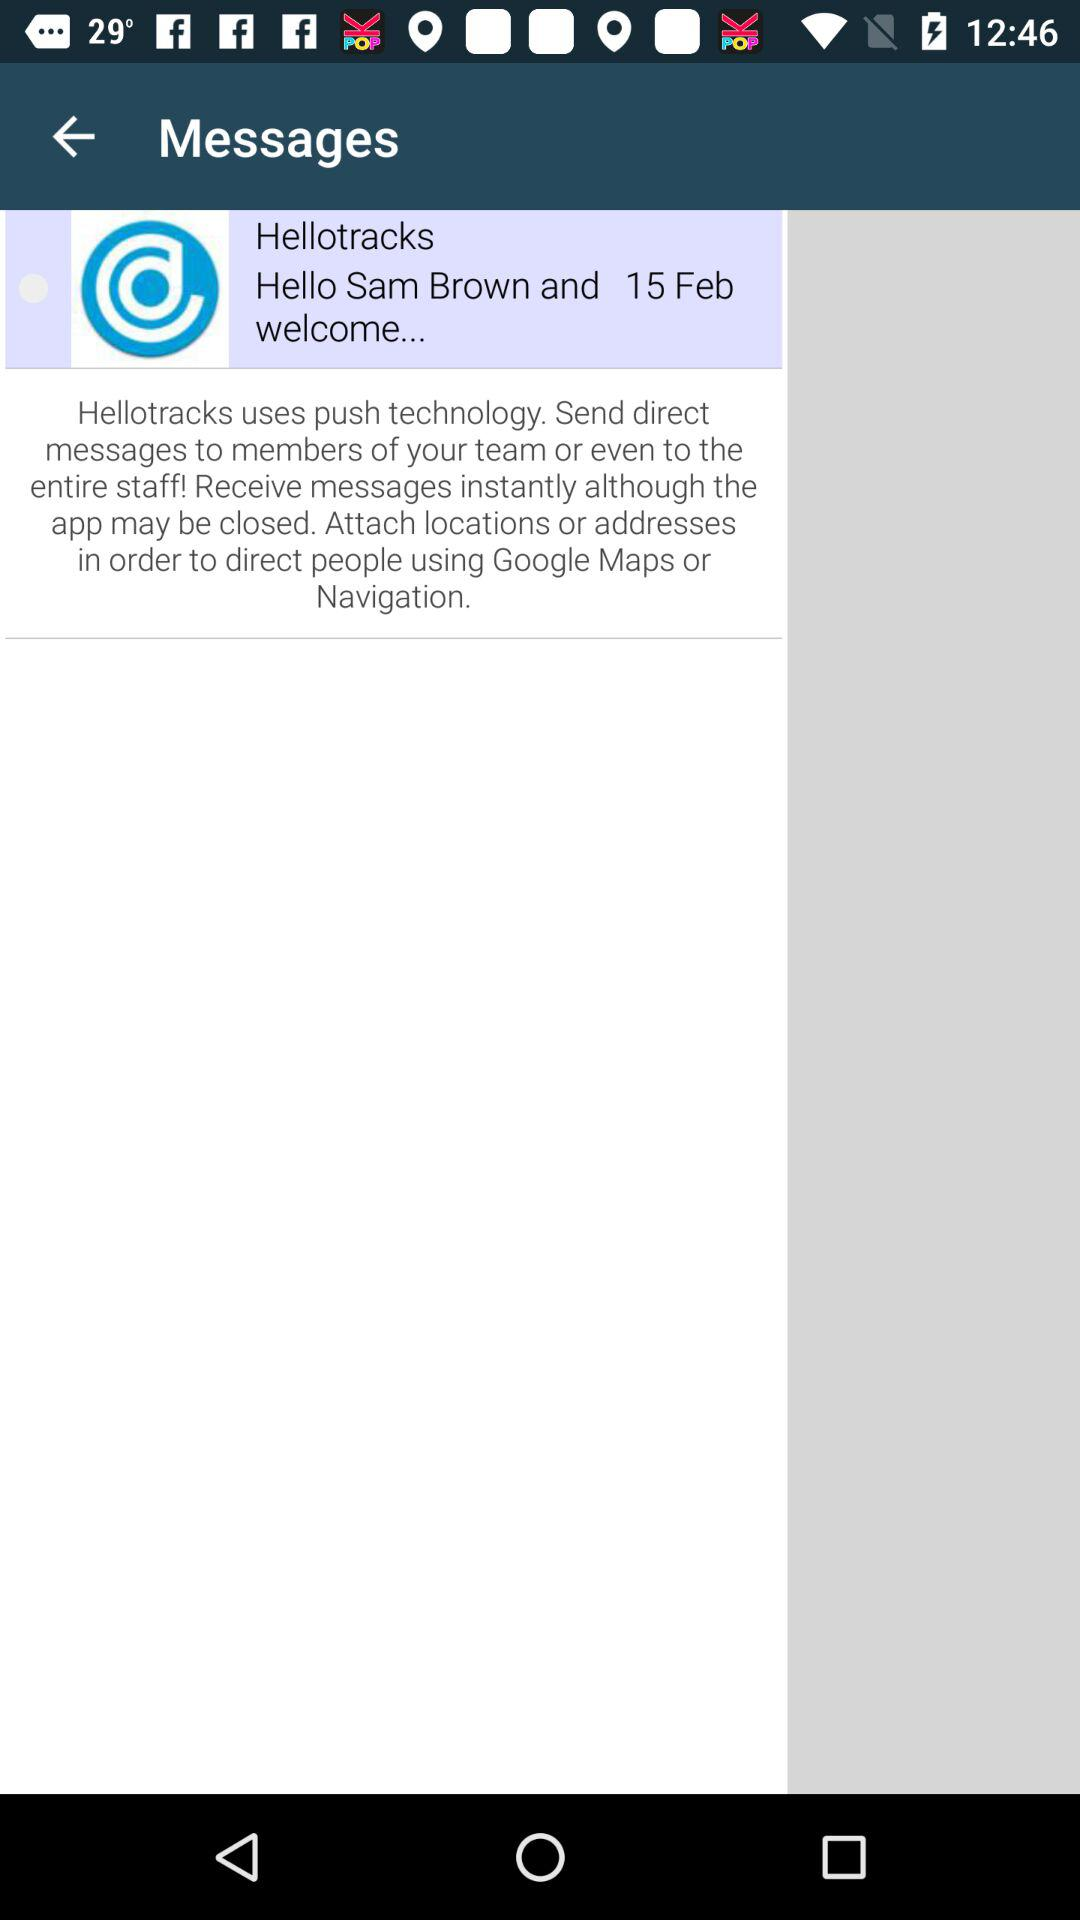What is the name of the application? The name of the application is "Hellotracks". 